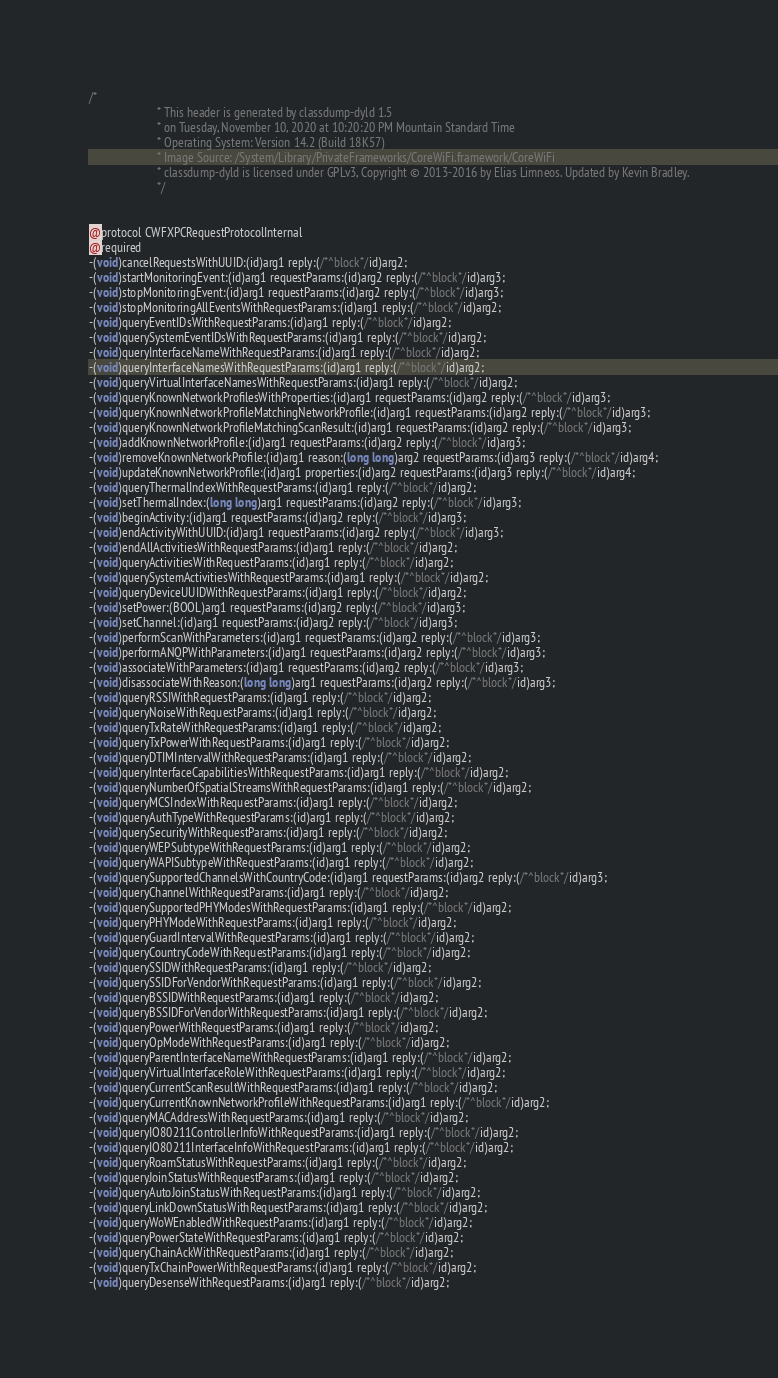Convert code to text. <code><loc_0><loc_0><loc_500><loc_500><_C_>/*
                       * This header is generated by classdump-dyld 1.5
                       * on Tuesday, November 10, 2020 at 10:20:20 PM Mountain Standard Time
                       * Operating System: Version 14.2 (Build 18K57)
                       * Image Source: /System/Library/PrivateFrameworks/CoreWiFi.framework/CoreWiFi
                       * classdump-dyld is licensed under GPLv3, Copyright © 2013-2016 by Elias Limneos. Updated by Kevin Bradley.
                       */


@protocol CWFXPCRequestProtocolInternal
@required
-(void)cancelRequestsWithUUID:(id)arg1 reply:(/*^block*/id)arg2;
-(void)startMonitoringEvent:(id)arg1 requestParams:(id)arg2 reply:(/*^block*/id)arg3;
-(void)stopMonitoringEvent:(id)arg1 requestParams:(id)arg2 reply:(/*^block*/id)arg3;
-(void)stopMonitoringAllEventsWithRequestParams:(id)arg1 reply:(/*^block*/id)arg2;
-(void)queryEventIDsWithRequestParams:(id)arg1 reply:(/*^block*/id)arg2;
-(void)querySystemEventIDsWithRequestParams:(id)arg1 reply:(/*^block*/id)arg2;
-(void)queryInterfaceNameWithRequestParams:(id)arg1 reply:(/*^block*/id)arg2;
-(void)queryInterfaceNamesWithRequestParams:(id)arg1 reply:(/*^block*/id)arg2;
-(void)queryVirtualInterfaceNamesWithRequestParams:(id)arg1 reply:(/*^block*/id)arg2;
-(void)queryKnownNetworkProfilesWithProperties:(id)arg1 requestParams:(id)arg2 reply:(/*^block*/id)arg3;
-(void)queryKnownNetworkProfileMatchingNetworkProfile:(id)arg1 requestParams:(id)arg2 reply:(/*^block*/id)arg3;
-(void)queryKnownNetworkProfileMatchingScanResult:(id)arg1 requestParams:(id)arg2 reply:(/*^block*/id)arg3;
-(void)addKnownNetworkProfile:(id)arg1 requestParams:(id)arg2 reply:(/*^block*/id)arg3;
-(void)removeKnownNetworkProfile:(id)arg1 reason:(long long)arg2 requestParams:(id)arg3 reply:(/*^block*/id)arg4;
-(void)updateKnownNetworkProfile:(id)arg1 properties:(id)arg2 requestParams:(id)arg3 reply:(/*^block*/id)arg4;
-(void)queryThermalIndexWithRequestParams:(id)arg1 reply:(/*^block*/id)arg2;
-(void)setThermalIndex:(long long)arg1 requestParams:(id)arg2 reply:(/*^block*/id)arg3;
-(void)beginActivity:(id)arg1 requestParams:(id)arg2 reply:(/*^block*/id)arg3;
-(void)endActivityWithUUID:(id)arg1 requestParams:(id)arg2 reply:(/*^block*/id)arg3;
-(void)endAllActivitiesWithRequestParams:(id)arg1 reply:(/*^block*/id)arg2;
-(void)queryActivitiesWithRequestParams:(id)arg1 reply:(/*^block*/id)arg2;
-(void)querySystemActivitiesWithRequestParams:(id)arg1 reply:(/*^block*/id)arg2;
-(void)queryDeviceUUIDWithRequestParams:(id)arg1 reply:(/*^block*/id)arg2;
-(void)setPower:(BOOL)arg1 requestParams:(id)arg2 reply:(/*^block*/id)arg3;
-(void)setChannel:(id)arg1 requestParams:(id)arg2 reply:(/*^block*/id)arg3;
-(void)performScanWithParameters:(id)arg1 requestParams:(id)arg2 reply:(/*^block*/id)arg3;
-(void)performANQPWithParameters:(id)arg1 requestParams:(id)arg2 reply:(/*^block*/id)arg3;
-(void)associateWithParameters:(id)arg1 requestParams:(id)arg2 reply:(/*^block*/id)arg3;
-(void)disassociateWithReason:(long long)arg1 requestParams:(id)arg2 reply:(/*^block*/id)arg3;
-(void)queryRSSIWithRequestParams:(id)arg1 reply:(/*^block*/id)arg2;
-(void)queryNoiseWithRequestParams:(id)arg1 reply:(/*^block*/id)arg2;
-(void)queryTxRateWithRequestParams:(id)arg1 reply:(/*^block*/id)arg2;
-(void)queryTxPowerWithRequestParams:(id)arg1 reply:(/*^block*/id)arg2;
-(void)queryDTIMIntervalWithRequestParams:(id)arg1 reply:(/*^block*/id)arg2;
-(void)queryInterfaceCapabilitiesWithRequestParams:(id)arg1 reply:(/*^block*/id)arg2;
-(void)queryNumberOfSpatialStreamsWithRequestParams:(id)arg1 reply:(/*^block*/id)arg2;
-(void)queryMCSIndexWithRequestParams:(id)arg1 reply:(/*^block*/id)arg2;
-(void)queryAuthTypeWithRequestParams:(id)arg1 reply:(/*^block*/id)arg2;
-(void)querySecurityWithRequestParams:(id)arg1 reply:(/*^block*/id)arg2;
-(void)queryWEPSubtypeWithRequestParams:(id)arg1 reply:(/*^block*/id)arg2;
-(void)queryWAPISubtypeWithRequestParams:(id)arg1 reply:(/*^block*/id)arg2;
-(void)querySupportedChannelsWithCountryCode:(id)arg1 requestParams:(id)arg2 reply:(/*^block*/id)arg3;
-(void)queryChannelWithRequestParams:(id)arg1 reply:(/*^block*/id)arg2;
-(void)querySupportedPHYModesWithRequestParams:(id)arg1 reply:(/*^block*/id)arg2;
-(void)queryPHYModeWithRequestParams:(id)arg1 reply:(/*^block*/id)arg2;
-(void)queryGuardIntervalWithRequestParams:(id)arg1 reply:(/*^block*/id)arg2;
-(void)queryCountryCodeWithRequestParams:(id)arg1 reply:(/*^block*/id)arg2;
-(void)querySSIDWithRequestParams:(id)arg1 reply:(/*^block*/id)arg2;
-(void)querySSIDForVendorWithRequestParams:(id)arg1 reply:(/*^block*/id)arg2;
-(void)queryBSSIDWithRequestParams:(id)arg1 reply:(/*^block*/id)arg2;
-(void)queryBSSIDForVendorWithRequestParams:(id)arg1 reply:(/*^block*/id)arg2;
-(void)queryPowerWithRequestParams:(id)arg1 reply:(/*^block*/id)arg2;
-(void)queryOpModeWithRequestParams:(id)arg1 reply:(/*^block*/id)arg2;
-(void)queryParentInterfaceNameWithRequestParams:(id)arg1 reply:(/*^block*/id)arg2;
-(void)queryVirtualInterfaceRoleWithRequestParams:(id)arg1 reply:(/*^block*/id)arg2;
-(void)queryCurrentScanResultWithRequestParams:(id)arg1 reply:(/*^block*/id)arg2;
-(void)queryCurrentKnownNetworkProfileWithRequestParams:(id)arg1 reply:(/*^block*/id)arg2;
-(void)queryMACAddressWithRequestParams:(id)arg1 reply:(/*^block*/id)arg2;
-(void)queryIO80211ControllerInfoWithRequestParams:(id)arg1 reply:(/*^block*/id)arg2;
-(void)queryIO80211InterfaceInfoWithRequestParams:(id)arg1 reply:(/*^block*/id)arg2;
-(void)queryRoamStatusWithRequestParams:(id)arg1 reply:(/*^block*/id)arg2;
-(void)queryJoinStatusWithRequestParams:(id)arg1 reply:(/*^block*/id)arg2;
-(void)queryAutoJoinStatusWithRequestParams:(id)arg1 reply:(/*^block*/id)arg2;
-(void)queryLinkDownStatusWithRequestParams:(id)arg1 reply:(/*^block*/id)arg2;
-(void)queryWoWEnabledWithRequestParams:(id)arg1 reply:(/*^block*/id)arg2;
-(void)queryPowerStateWithRequestParams:(id)arg1 reply:(/*^block*/id)arg2;
-(void)queryChainAckWithRequestParams:(id)arg1 reply:(/*^block*/id)arg2;
-(void)queryTxChainPowerWithRequestParams:(id)arg1 reply:(/*^block*/id)arg2;
-(void)queryDesenseWithRequestParams:(id)arg1 reply:(/*^block*/id)arg2;</code> 